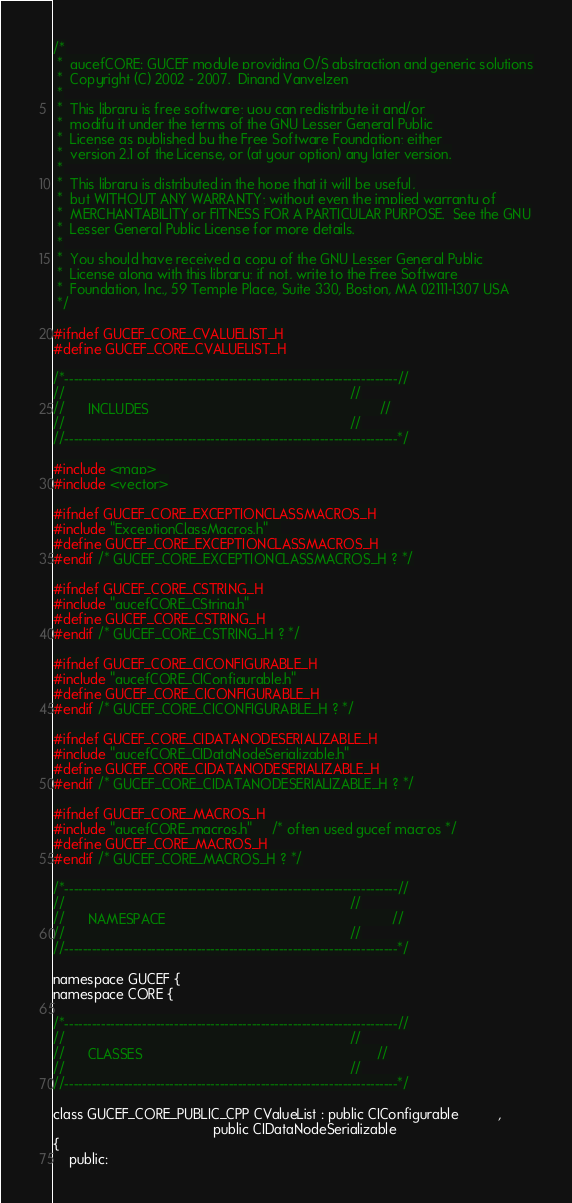Convert code to text. <code><loc_0><loc_0><loc_500><loc_500><_C_>/*
 *  gucefCORE: GUCEF module providing O/S abstraction and generic solutions
 *  Copyright (C) 2002 - 2007.  Dinand Vanvelzen
 *
 *  This library is free software; you can redistribute it and/or
 *  modify it under the terms of the GNU Lesser General Public
 *  License as published by the Free Software Foundation; either
 *  version 2.1 of the License, or (at your option) any later version.
 *
 *  This library is distributed in the hope that it will be useful,
 *  but WITHOUT ANY WARRANTY; without even the implied warranty of
 *  MERCHANTABILITY or FITNESS FOR A PARTICULAR PURPOSE.  See the GNU
 *  Lesser General Public License for more details.
 *
 *  You should have received a copy of the GNU Lesser General Public
 *  License along with this library; if not, write to the Free Software
 *  Foundation, Inc., 59 Temple Place, Suite 330, Boston, MA 02111-1307 USA
 */

#ifndef GUCEF_CORE_CVALUELIST_H
#define GUCEF_CORE_CVALUELIST_H

/*-------------------------------------------------------------------------//
//                                                                         //
//      INCLUDES                                                           //
//                                                                         //
//-------------------------------------------------------------------------*/

#include <map>
#include <vector>

#ifndef GUCEF_CORE_EXCEPTIONCLASSMACROS_H
#include "ExceptionClassMacros.h"   
#define GUCEF_CORE_EXCEPTIONCLASSMACROS_H
#endif /* GUCEF_CORE_EXCEPTIONCLASSMACROS_H ? */

#ifndef GUCEF_CORE_CSTRING_H
#include "gucefCORE_CString.h"
#define GUCEF_CORE_CSTRING_H
#endif /* GUCEF_CORE_CSTRING_H ? */

#ifndef GUCEF_CORE_CICONFIGURABLE_H
#include "gucefCORE_CIConfigurable.h"
#define GUCEF_CORE_CICONFIGURABLE_H
#endif /* GUCEF_CORE_CICONFIGURABLE_H ? */

#ifndef GUCEF_CORE_CIDATANODESERIALIZABLE_H
#include "gucefCORE_CIDataNodeSerializable.h"
#define GUCEF_CORE_CIDATANODESERIALIZABLE_H
#endif /* GUCEF_CORE_CIDATANODESERIALIZABLE_H ? */

#ifndef GUCEF_CORE_MACROS_H
#include "gucefCORE_macros.h"     /* often used gucef macros */
#define GUCEF_CORE_MACROS_H
#endif /* GUCEF_CORE_MACROS_H ? */

/*-------------------------------------------------------------------------//
//                                                                         //
//      NAMESPACE                                                          //
//                                                                         //
//-------------------------------------------------------------------------*/

namespace GUCEF {
namespace CORE {

/*-------------------------------------------------------------------------//
//                                                                         //
//      CLASSES                                                            //
//                                                                         //
//-------------------------------------------------------------------------*/

class GUCEF_CORE_PUBLIC_CPP CValueList : public CIConfigurable          ,
                                         public CIDataNodeSerializable
{
    public:
</code> 